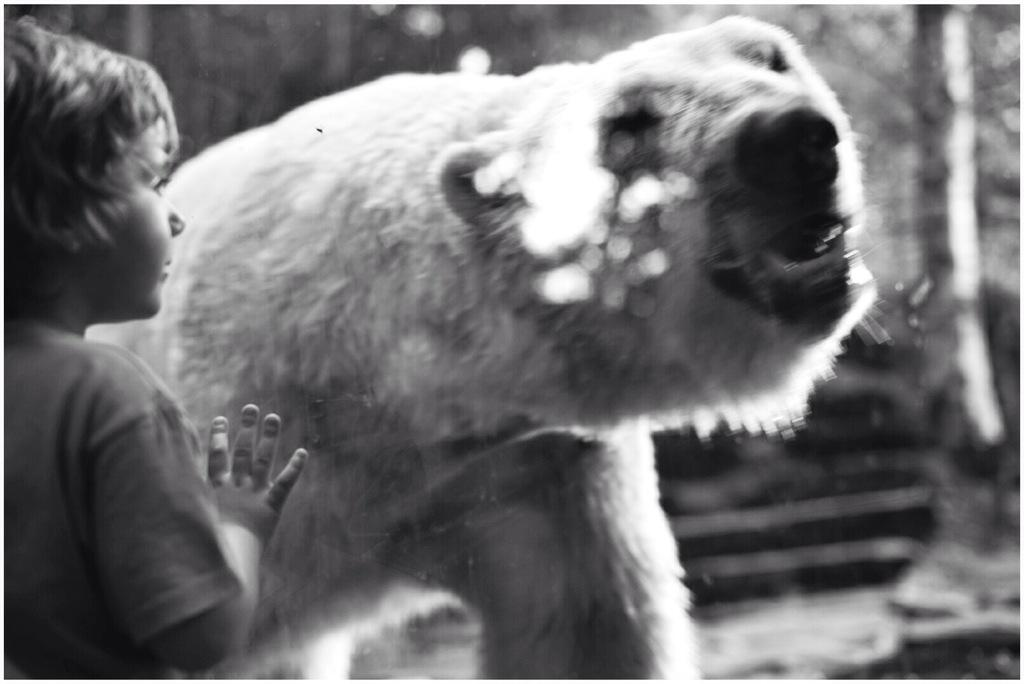What is the main subject of the image? The main subject of the image is a small boy. What is the boy doing in the image? The boy is standing and watching through a glass. What animal can be seen in the image? There is a white color polar bear in the image. What can be seen in the background of the image? There are trees in the background of the image. What type of plant is the boy using to wash his hands in the image? There is no plant or hand-washing activity depicted in the image. 